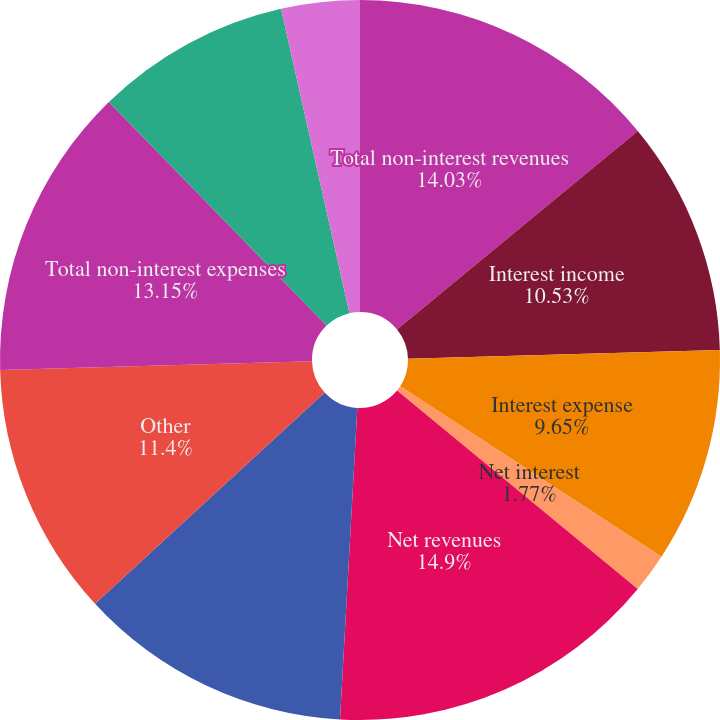<chart> <loc_0><loc_0><loc_500><loc_500><pie_chart><fcel>Total non-interest revenues<fcel>Interest income<fcel>Interest expense<fcel>Net interest<fcel>Net revenues<fcel>Compensation and benefits<fcel>Other<fcel>Total non-interest expenses<fcel>Income from continuing<fcel>Provision for (benefit from)<nl><fcel>14.03%<fcel>10.53%<fcel>9.65%<fcel>1.77%<fcel>14.91%<fcel>12.28%<fcel>11.4%<fcel>13.15%<fcel>8.77%<fcel>3.52%<nl></chart> 